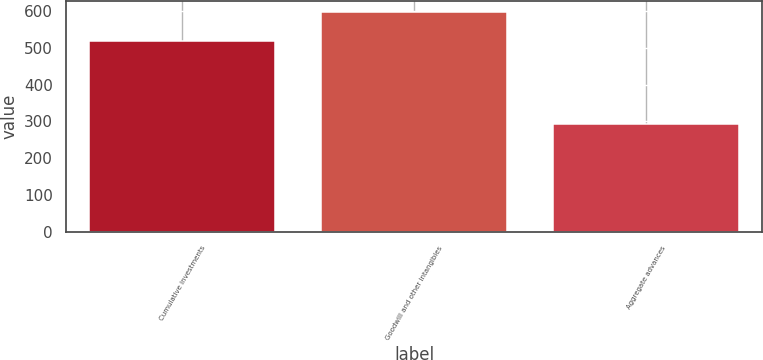Convert chart to OTSL. <chart><loc_0><loc_0><loc_500><loc_500><bar_chart><fcel>Cumulative investments<fcel>Goodwill and other intangibles<fcel>Aggregate advances<nl><fcel>519.1<fcel>597.1<fcel>293.3<nl></chart> 